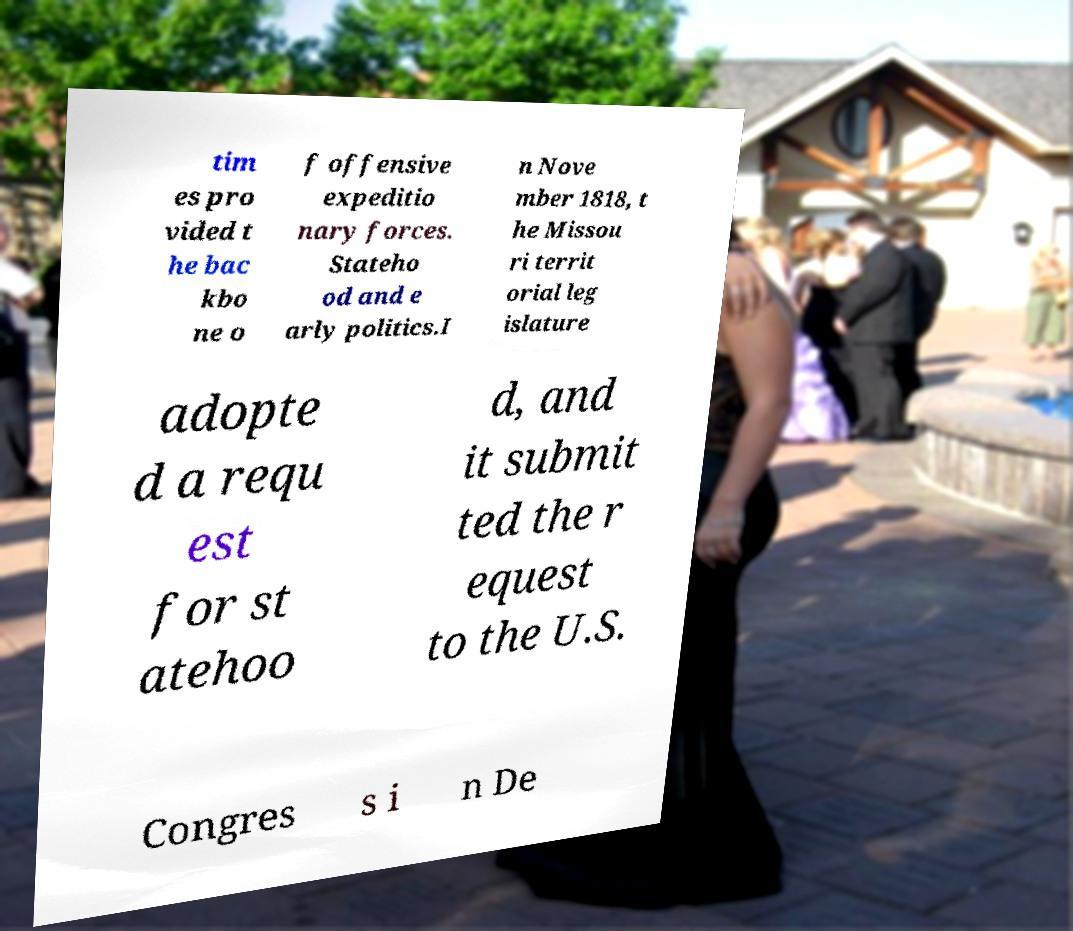For documentation purposes, I need the text within this image transcribed. Could you provide that? tim es pro vided t he bac kbo ne o f offensive expeditio nary forces. Stateho od and e arly politics.I n Nove mber 1818, t he Missou ri territ orial leg islature adopte d a requ est for st atehoo d, and it submit ted the r equest to the U.S. Congres s i n De 